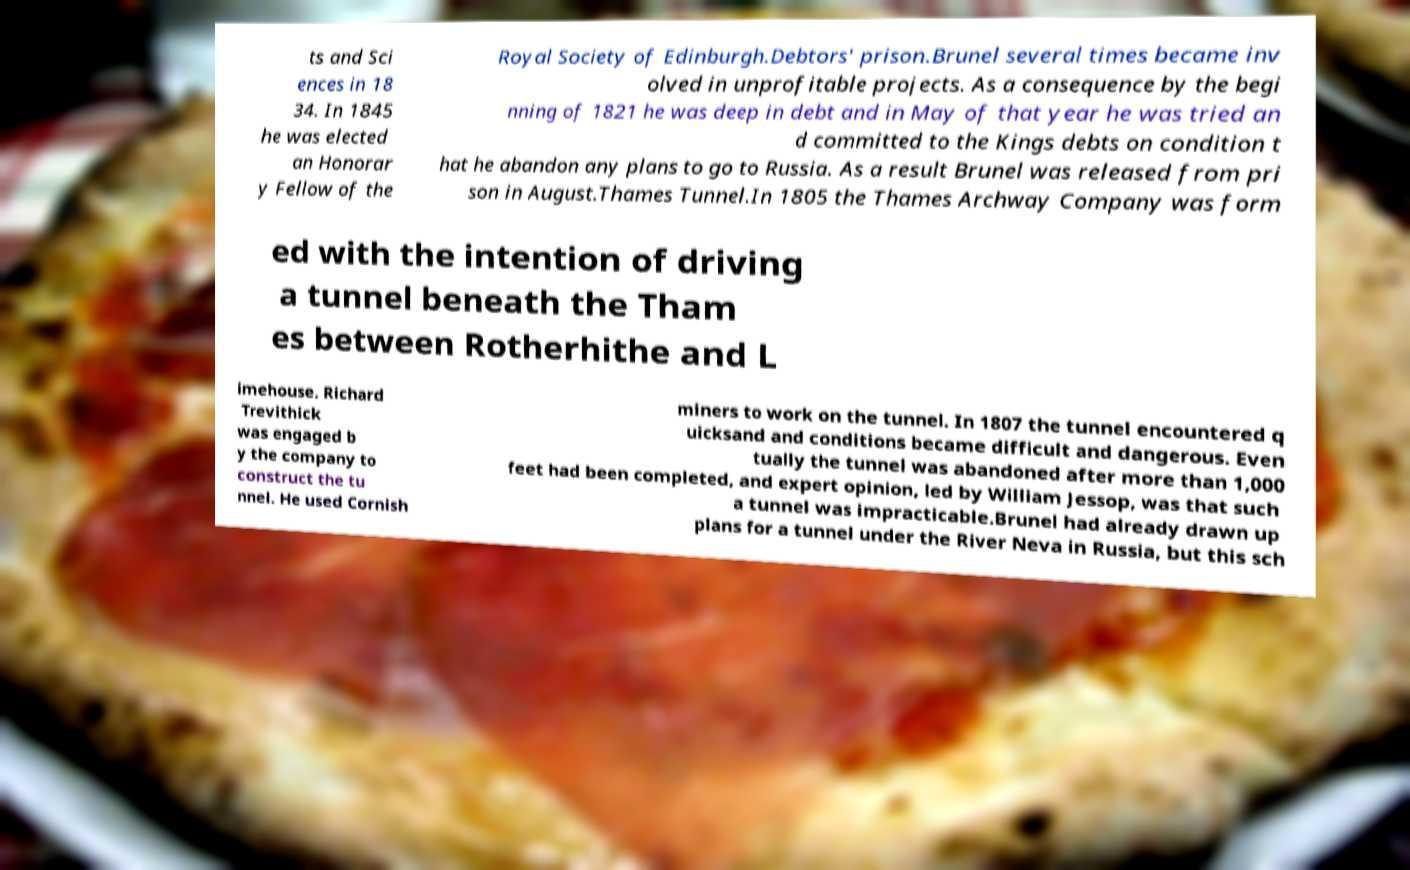Please identify and transcribe the text found in this image. ts and Sci ences in 18 34. In 1845 he was elected an Honorar y Fellow of the Royal Society of Edinburgh.Debtors' prison.Brunel several times became inv olved in unprofitable projects. As a consequence by the begi nning of 1821 he was deep in debt and in May of that year he was tried an d committed to the Kings debts on condition t hat he abandon any plans to go to Russia. As a result Brunel was released from pri son in August.Thames Tunnel.In 1805 the Thames Archway Company was form ed with the intention of driving a tunnel beneath the Tham es between Rotherhithe and L imehouse. Richard Trevithick was engaged b y the company to construct the tu nnel. He used Cornish miners to work on the tunnel. In 1807 the tunnel encountered q uicksand and conditions became difficult and dangerous. Even tually the tunnel was abandoned after more than 1,000 feet had been completed, and expert opinion, led by William Jessop, was that such a tunnel was impracticable.Brunel had already drawn up plans for a tunnel under the River Neva in Russia, but this sch 